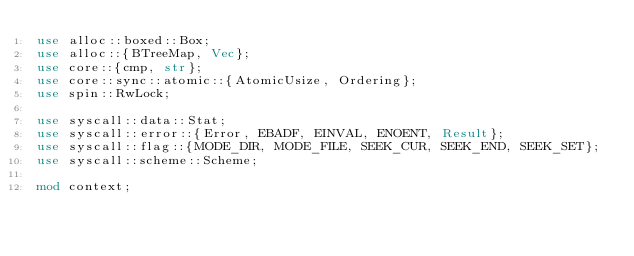<code> <loc_0><loc_0><loc_500><loc_500><_Rust_>use alloc::boxed::Box;
use alloc::{BTreeMap, Vec};
use core::{cmp, str};
use core::sync::atomic::{AtomicUsize, Ordering};
use spin::RwLock;

use syscall::data::Stat;
use syscall::error::{Error, EBADF, EINVAL, ENOENT, Result};
use syscall::flag::{MODE_DIR, MODE_FILE, SEEK_CUR, SEEK_END, SEEK_SET};
use syscall::scheme::Scheme;

mod context;</code> 